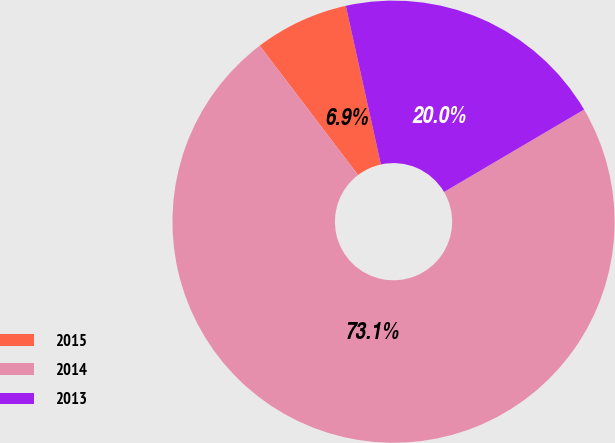<chart> <loc_0><loc_0><loc_500><loc_500><pie_chart><fcel>2015<fcel>2014<fcel>2013<nl><fcel>6.88%<fcel>73.12%<fcel>20.0%<nl></chart> 